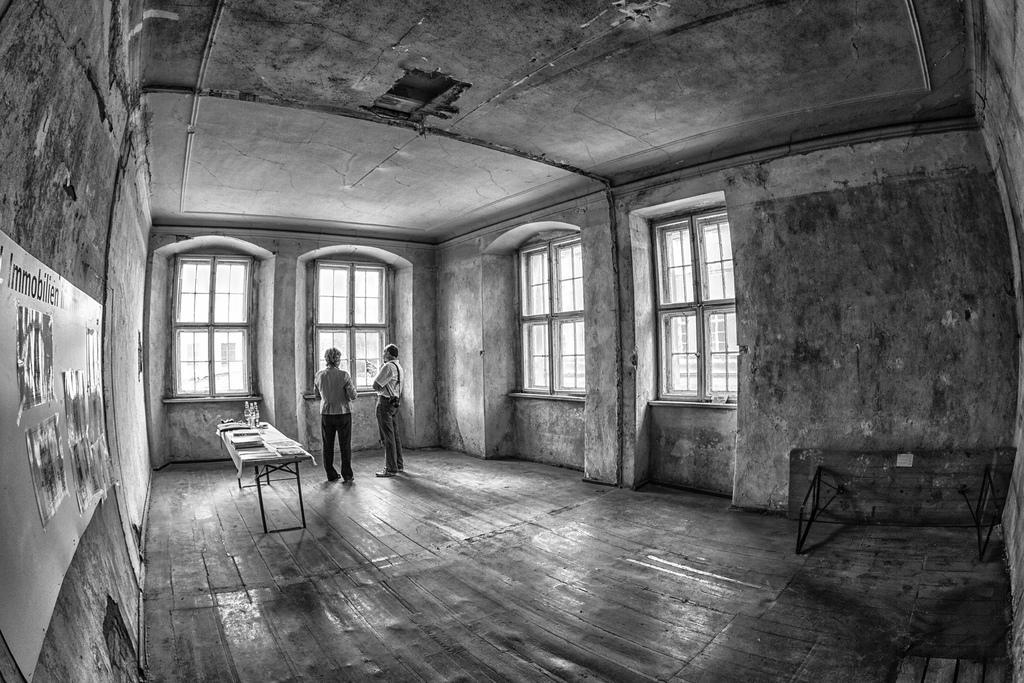In one or two sentences, can you explain what this image depicts? In the picture we can see a house hall in it, we can see two people are standing and talking and besides them, we can see a table with a tablecloth on it and some papers and things on it and in the background we can see a wall with some windows and some board with some photos to it. 